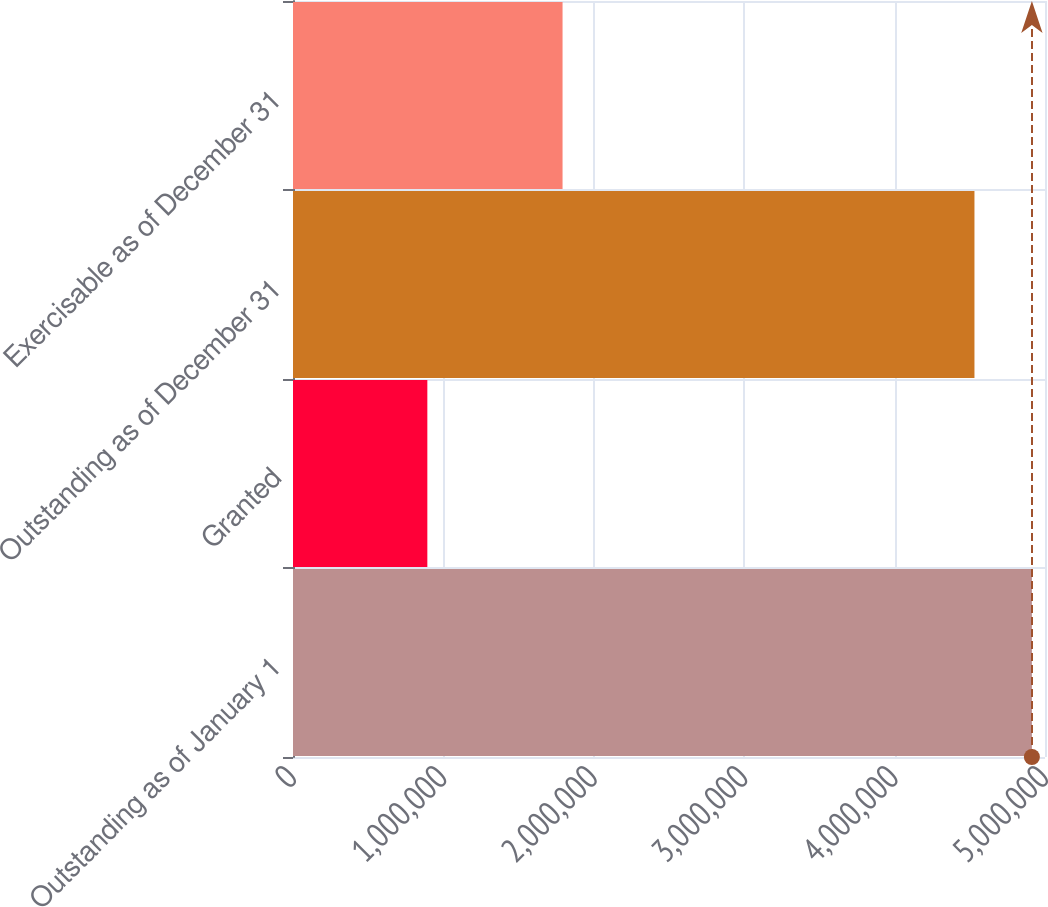Convert chart to OTSL. <chart><loc_0><loc_0><loc_500><loc_500><bar_chart><fcel>Outstanding as of January 1<fcel>Granted<fcel>Outstanding as of December 31<fcel>Exercisable as of December 31<nl><fcel>4.91289e+06<fcel>893220<fcel>4.53098e+06<fcel>1.79224e+06<nl></chart> 